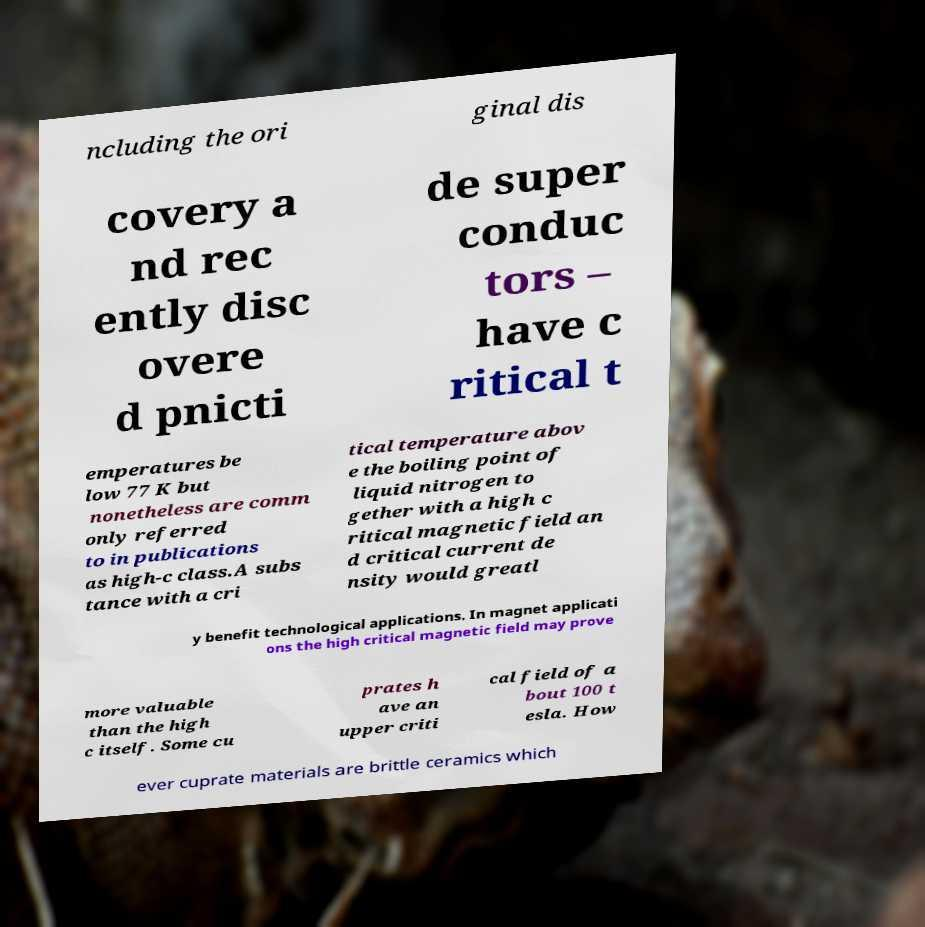Can you accurately transcribe the text from the provided image for me? ncluding the ori ginal dis covery a nd rec ently disc overe d pnicti de super conduc tors – have c ritical t emperatures be low 77 K but nonetheless are comm only referred to in publications as high-c class.A subs tance with a cri tical temperature abov e the boiling point of liquid nitrogen to gether with a high c ritical magnetic field an d critical current de nsity would greatl y benefit technological applications. In magnet applicati ons the high critical magnetic field may prove more valuable than the high c itself. Some cu prates h ave an upper criti cal field of a bout 100 t esla. How ever cuprate materials are brittle ceramics which 